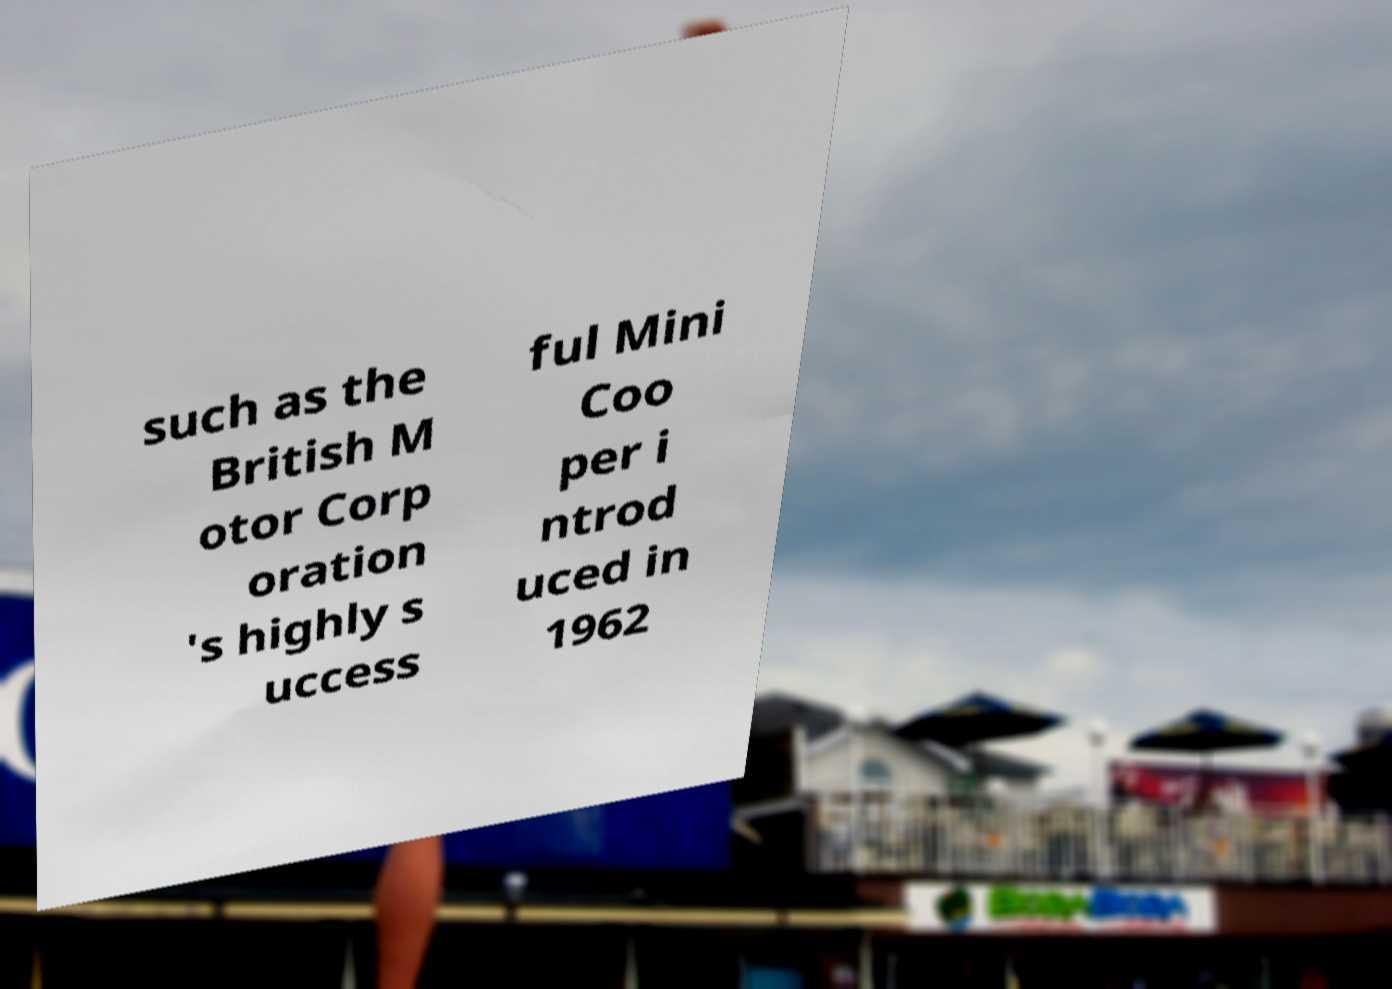Please identify and transcribe the text found in this image. such as the British M otor Corp oration 's highly s uccess ful Mini Coo per i ntrod uced in 1962 